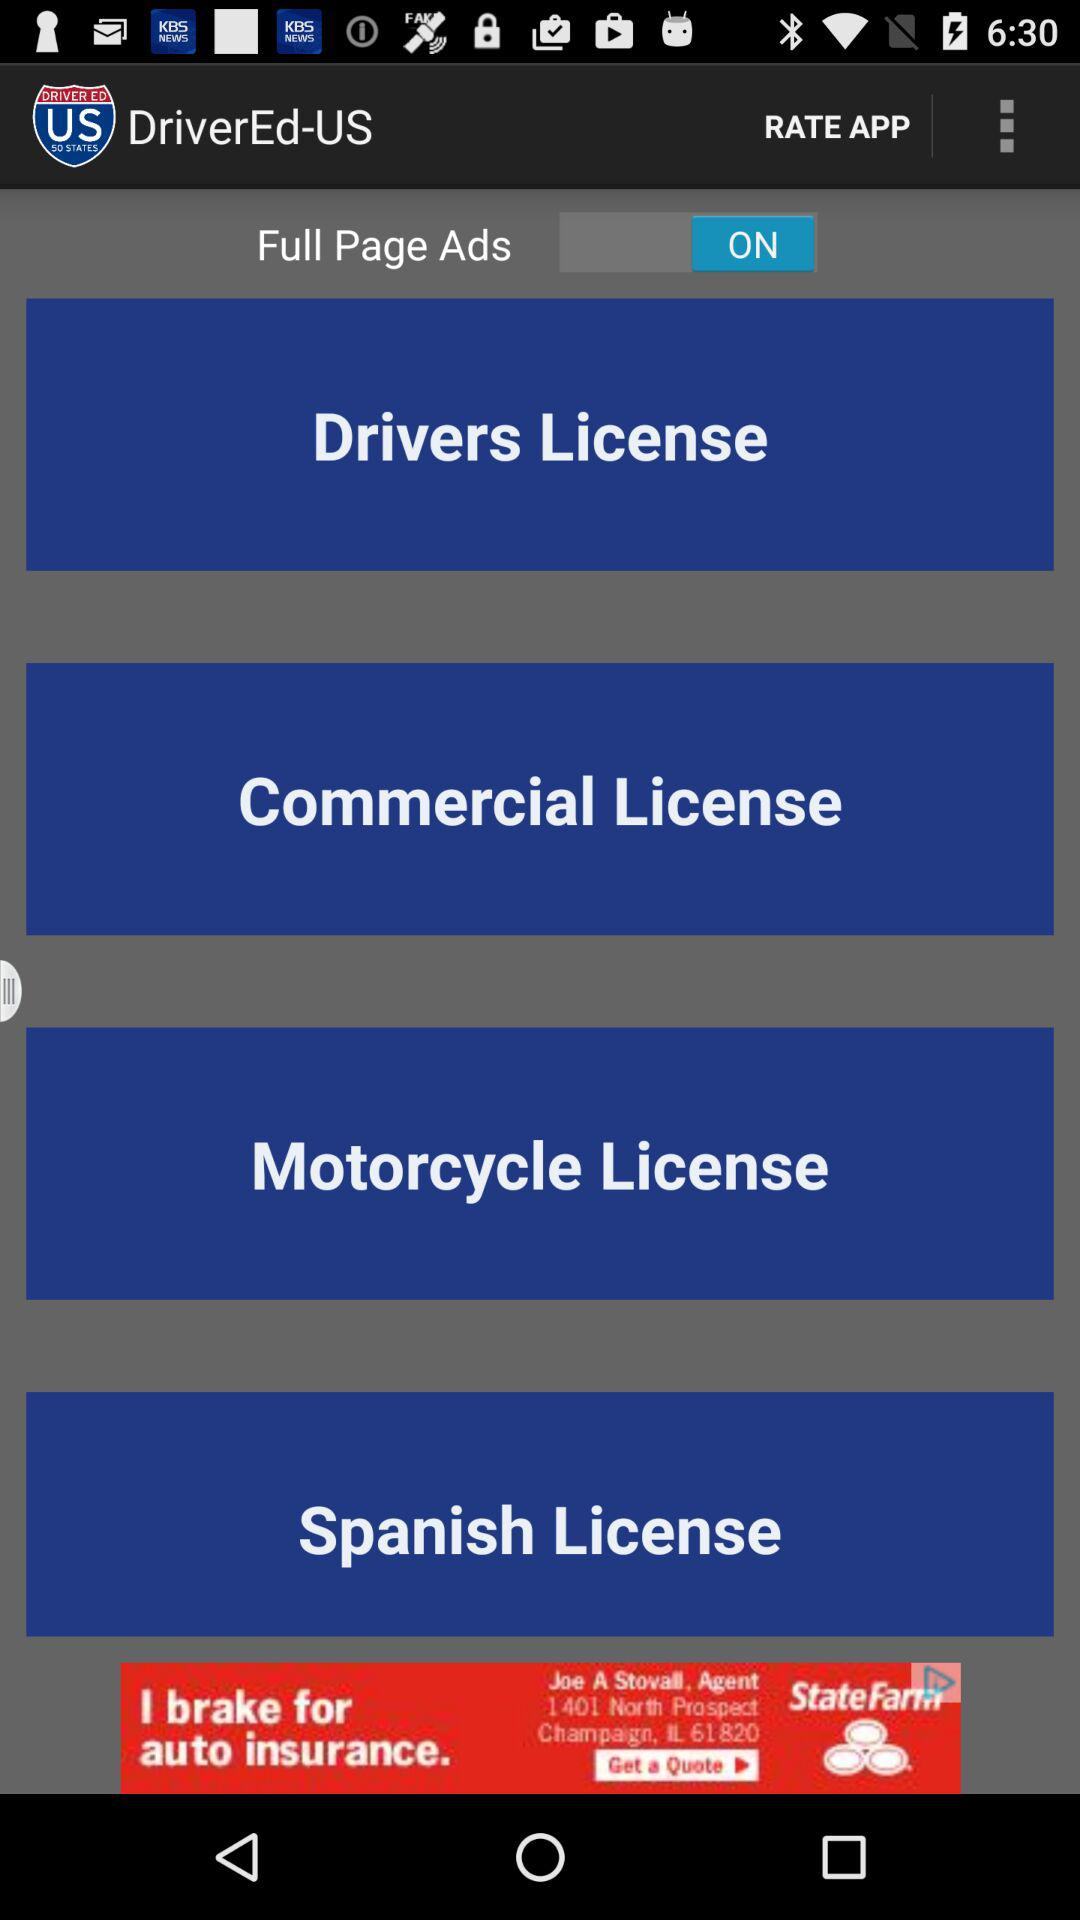What is the name of the application? The name of the application is "DriverEd-US". 